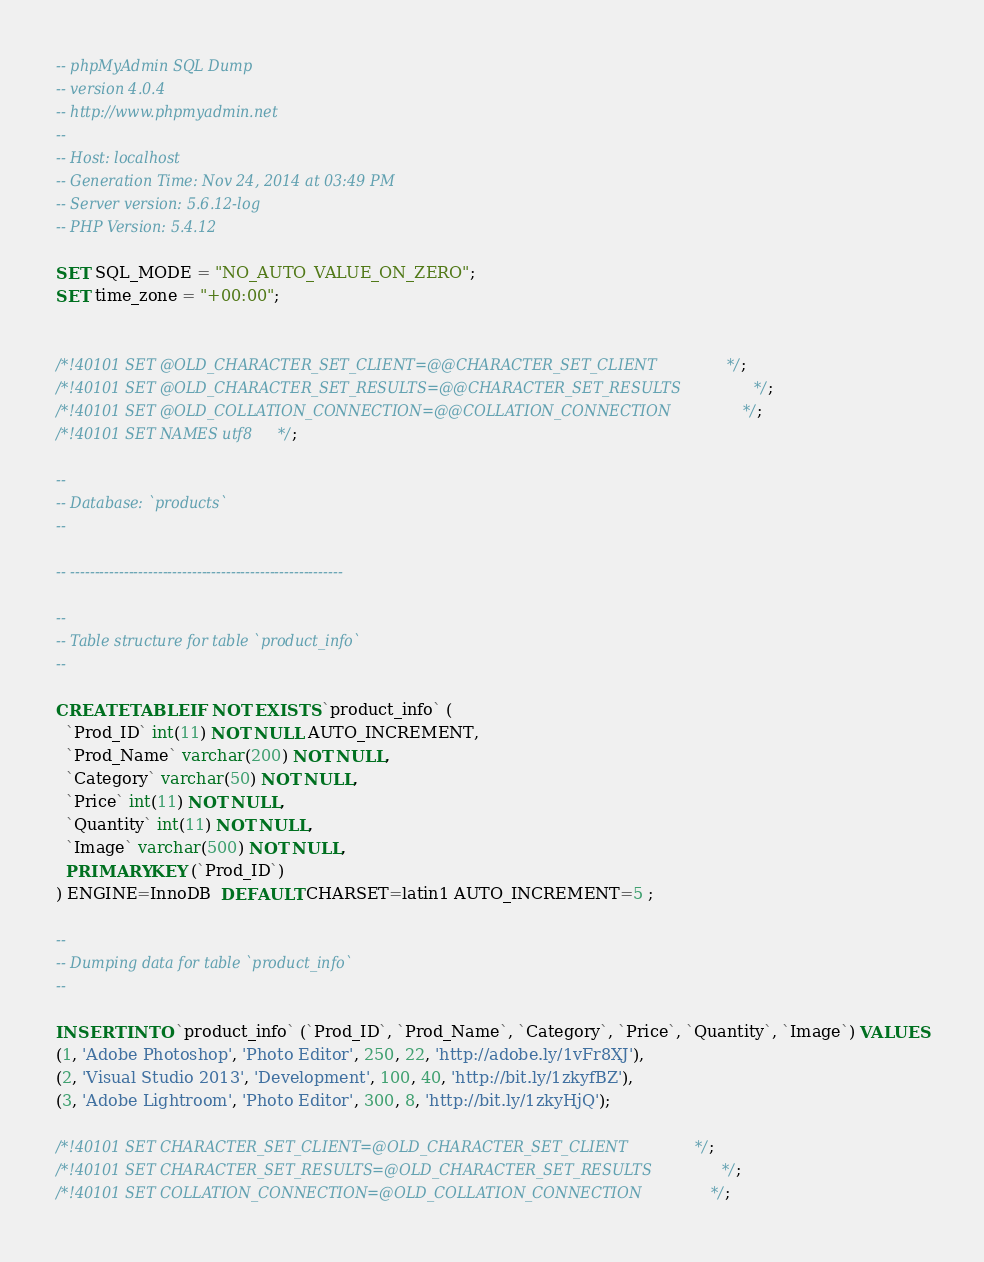<code> <loc_0><loc_0><loc_500><loc_500><_SQL_>-- phpMyAdmin SQL Dump
-- version 4.0.4
-- http://www.phpmyadmin.net
--
-- Host: localhost
-- Generation Time: Nov 24, 2014 at 03:49 PM
-- Server version: 5.6.12-log
-- PHP Version: 5.4.12

SET SQL_MODE = "NO_AUTO_VALUE_ON_ZERO";
SET time_zone = "+00:00";


/*!40101 SET @OLD_CHARACTER_SET_CLIENT=@@CHARACTER_SET_CLIENT */;
/*!40101 SET @OLD_CHARACTER_SET_RESULTS=@@CHARACTER_SET_RESULTS */;
/*!40101 SET @OLD_COLLATION_CONNECTION=@@COLLATION_CONNECTION */;
/*!40101 SET NAMES utf8 */;

--
-- Database: `products`
--

-- --------------------------------------------------------

--
-- Table structure for table `product_info`
--

CREATE TABLE IF NOT EXISTS `product_info` (
  `Prod_ID` int(11) NOT NULL AUTO_INCREMENT,
  `Prod_Name` varchar(200) NOT NULL,
  `Category` varchar(50) NOT NULL,
  `Price` int(11) NOT NULL,
  `Quantity` int(11) NOT NULL,
  `Image` varchar(500) NOT NULL,
  PRIMARY KEY (`Prod_ID`)
) ENGINE=InnoDB  DEFAULT CHARSET=latin1 AUTO_INCREMENT=5 ;

--
-- Dumping data for table `product_info`
--

INSERT INTO `product_info` (`Prod_ID`, `Prod_Name`, `Category`, `Price`, `Quantity`, `Image`) VALUES
(1, 'Adobe Photoshop', 'Photo Editor', 250, 22, 'http://adobe.ly/1vFr8XJ'),
(2, 'Visual Studio 2013', 'Development', 100, 40, 'http://bit.ly/1zkyfBZ'),
(3, 'Adobe Lightroom', 'Photo Editor', 300, 8, 'http://bit.ly/1zkyHjQ');

/*!40101 SET CHARACTER_SET_CLIENT=@OLD_CHARACTER_SET_CLIENT */;
/*!40101 SET CHARACTER_SET_RESULTS=@OLD_CHARACTER_SET_RESULTS */;
/*!40101 SET COLLATION_CONNECTION=@OLD_COLLATION_CONNECTION */;
</code> 